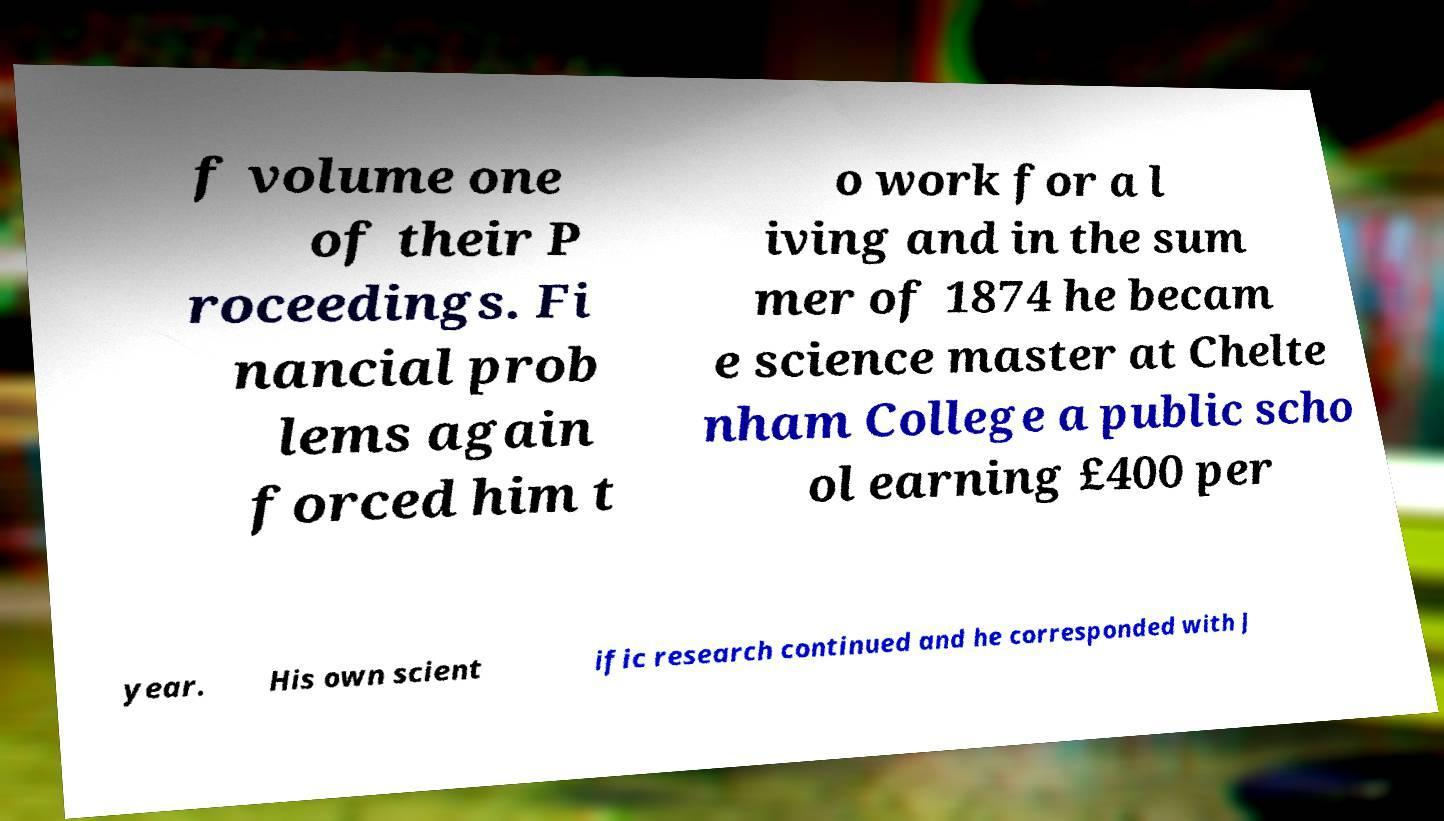Can you read and provide the text displayed in the image?This photo seems to have some interesting text. Can you extract and type it out for me? f volume one of their P roceedings. Fi nancial prob lems again forced him t o work for a l iving and in the sum mer of 1874 he becam e science master at Chelte nham College a public scho ol earning £400 per year. His own scient ific research continued and he corresponded with J 